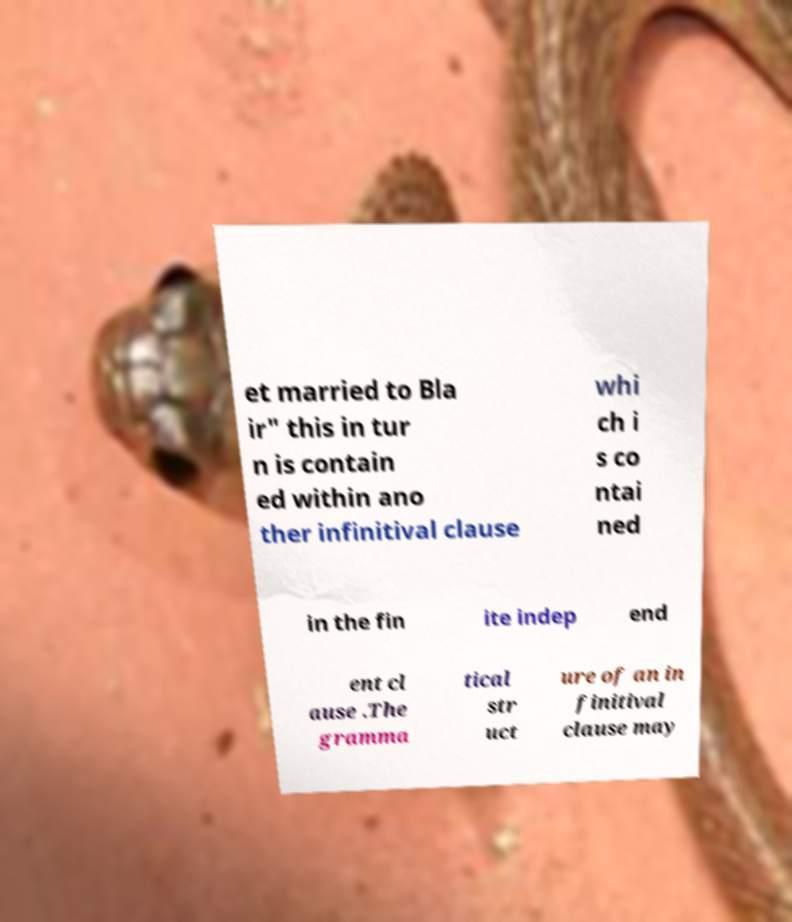Can you read and provide the text displayed in the image?This photo seems to have some interesting text. Can you extract and type it out for me? et married to Bla ir" this in tur n is contain ed within ano ther infinitival clause whi ch i s co ntai ned in the fin ite indep end ent cl ause .The gramma tical str uct ure of an in finitival clause may 